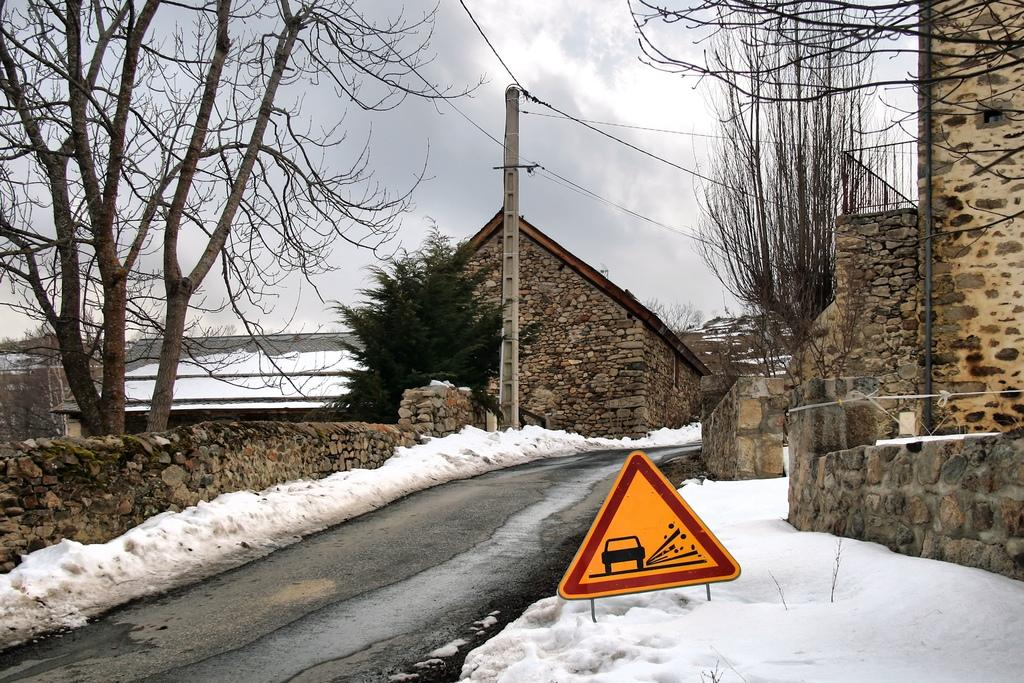What can be seen near the roadside in the image? There are houses and trees near the roadside in the image. What is the weather condition in the image? There is snow visible in the image, indicating a cold or wintery condition. How many boats are visible in the image? There are no boats present in the image. What type of wax can be seen melting on the road in the image? There is no wax present in the image, and therefore no such activity can be observed. 